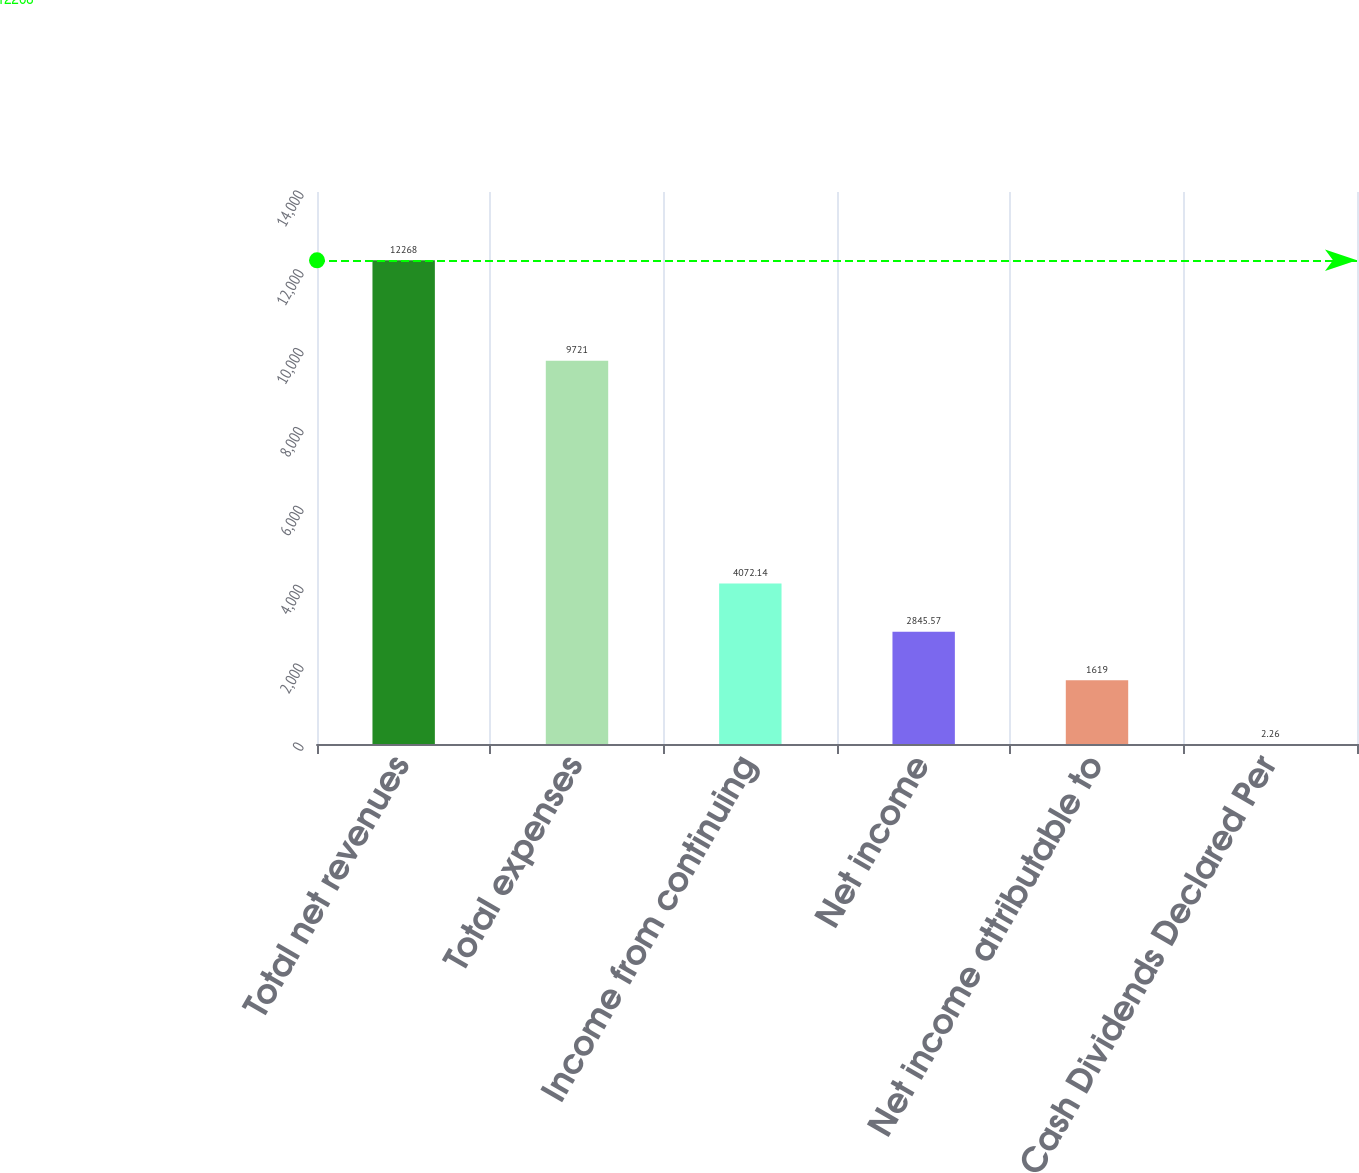Convert chart to OTSL. <chart><loc_0><loc_0><loc_500><loc_500><bar_chart><fcel>Total net revenues<fcel>Total expenses<fcel>Income from continuing<fcel>Net income<fcel>Net income attributable to<fcel>Cash Dividends Declared Per<nl><fcel>12268<fcel>9721<fcel>4072.14<fcel>2845.57<fcel>1619<fcel>2.26<nl></chart> 